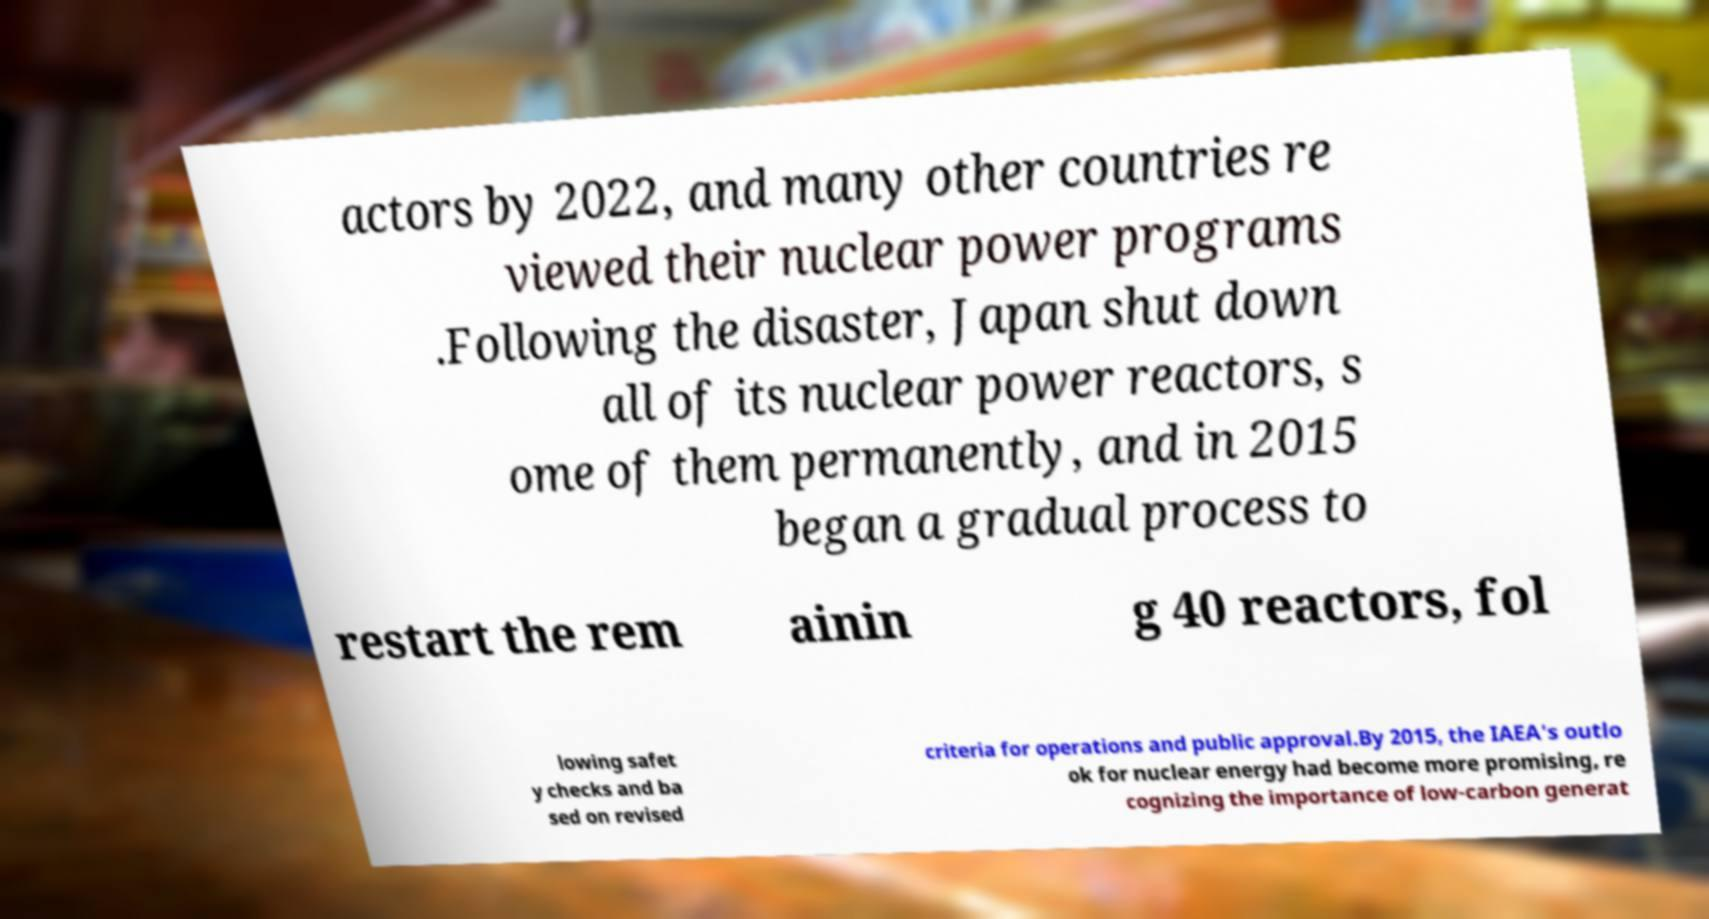Can you read and provide the text displayed in the image?This photo seems to have some interesting text. Can you extract and type it out for me? actors by 2022, and many other countries re viewed their nuclear power programs .Following the disaster, Japan shut down all of its nuclear power reactors, s ome of them permanently, and in 2015 began a gradual process to restart the rem ainin g 40 reactors, fol lowing safet y checks and ba sed on revised criteria for operations and public approval.By 2015, the IAEA's outlo ok for nuclear energy had become more promising, re cognizing the importance of low-carbon generat 